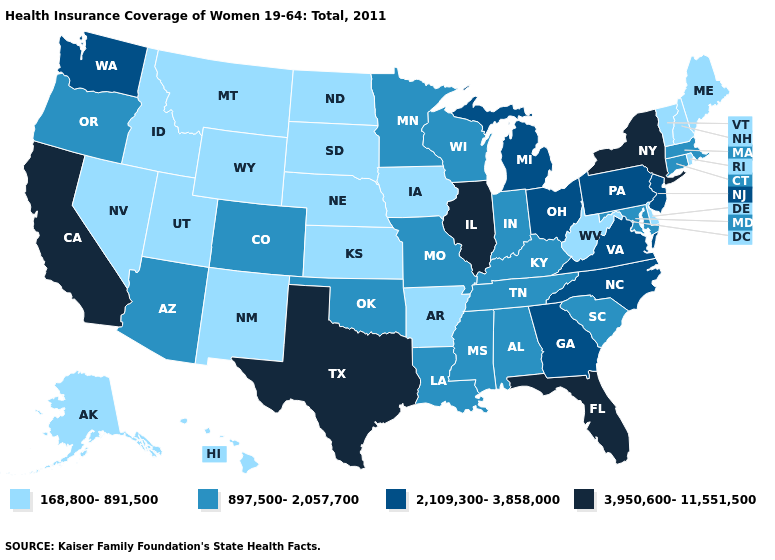Does Colorado have the highest value in the West?
Quick response, please. No. Does Vermont have the lowest value in the Northeast?
Be succinct. Yes. Name the states that have a value in the range 168,800-891,500?
Be succinct. Alaska, Arkansas, Delaware, Hawaii, Idaho, Iowa, Kansas, Maine, Montana, Nebraska, Nevada, New Hampshire, New Mexico, North Dakota, Rhode Island, South Dakota, Utah, Vermont, West Virginia, Wyoming. Among the states that border Washington , does Oregon have the lowest value?
Quick response, please. No. Does California have the highest value in the USA?
Answer briefly. Yes. What is the highest value in the West ?
Write a very short answer. 3,950,600-11,551,500. What is the highest value in the South ?
Be succinct. 3,950,600-11,551,500. Name the states that have a value in the range 168,800-891,500?
Quick response, please. Alaska, Arkansas, Delaware, Hawaii, Idaho, Iowa, Kansas, Maine, Montana, Nebraska, Nevada, New Hampshire, New Mexico, North Dakota, Rhode Island, South Dakota, Utah, Vermont, West Virginia, Wyoming. Name the states that have a value in the range 3,950,600-11,551,500?
Keep it brief. California, Florida, Illinois, New York, Texas. What is the value of Nebraska?
Keep it brief. 168,800-891,500. Name the states that have a value in the range 897,500-2,057,700?
Write a very short answer. Alabama, Arizona, Colorado, Connecticut, Indiana, Kentucky, Louisiana, Maryland, Massachusetts, Minnesota, Mississippi, Missouri, Oklahoma, Oregon, South Carolina, Tennessee, Wisconsin. What is the lowest value in the USA?
Answer briefly. 168,800-891,500. Name the states that have a value in the range 897,500-2,057,700?
Write a very short answer. Alabama, Arizona, Colorado, Connecticut, Indiana, Kentucky, Louisiana, Maryland, Massachusetts, Minnesota, Mississippi, Missouri, Oklahoma, Oregon, South Carolina, Tennessee, Wisconsin. Does Arizona have the highest value in the West?
Write a very short answer. No. 